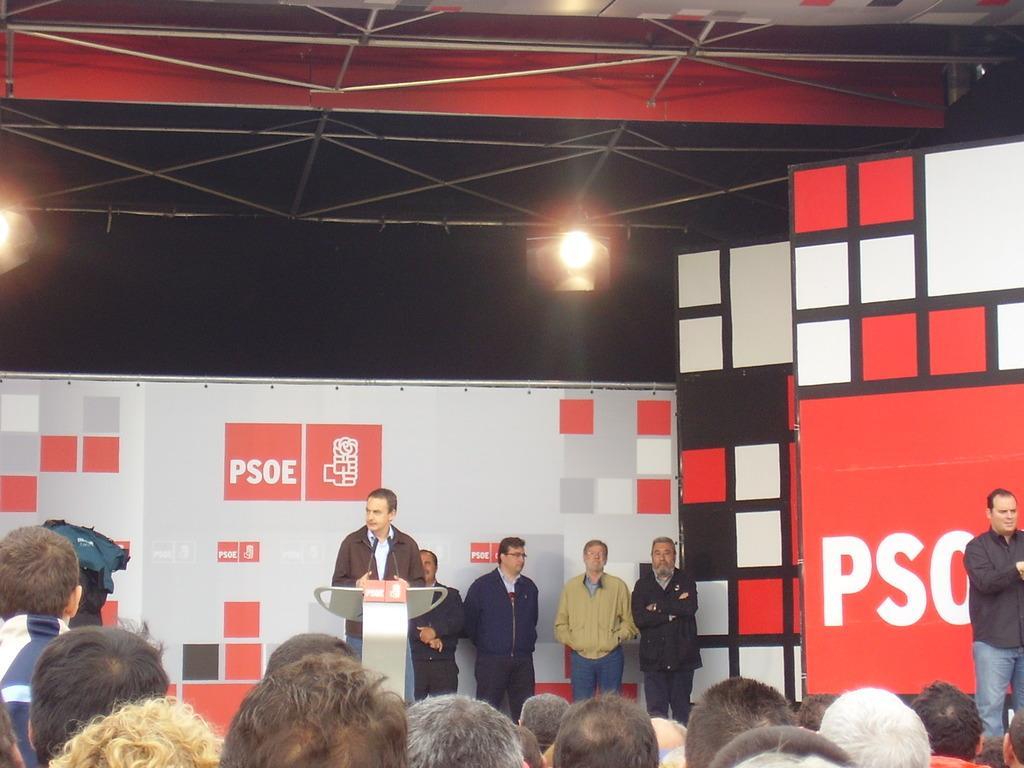In one or two sentences, can you explain what this image depicts? In the foreground of the picture we can see the heads of the people. In the middle of the picture there are banners, people, podium, mic and other objects. At the top we can see iron frames, flood lights and other object. In the center of the background it is dark. 